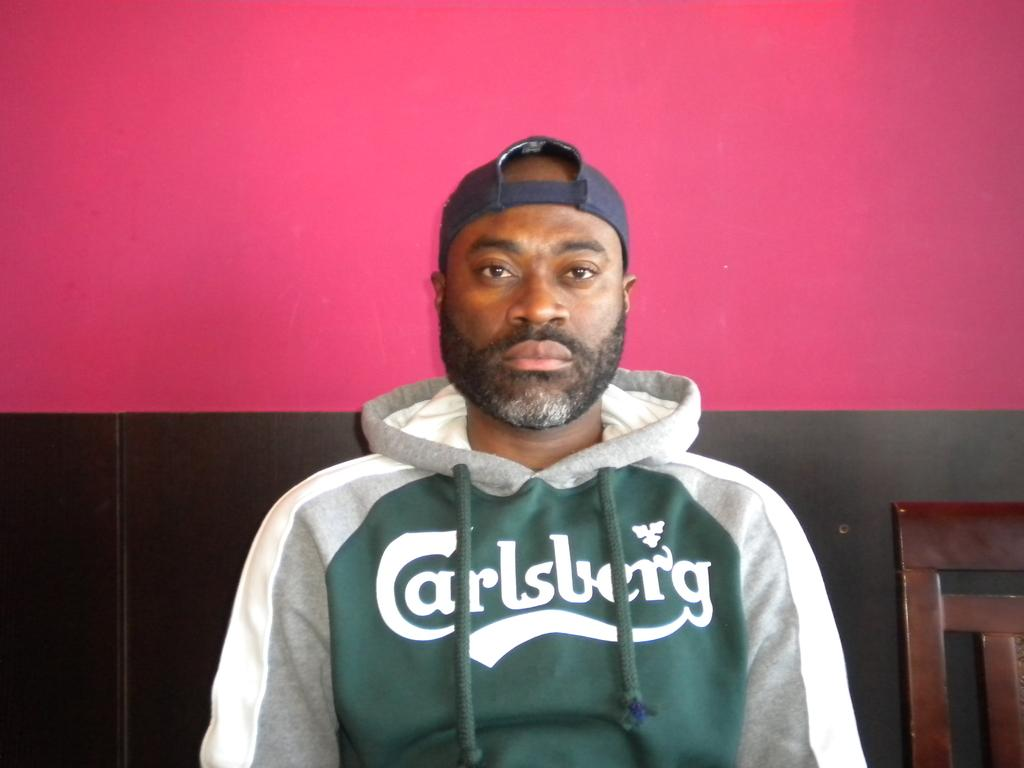<image>
Render a clear and concise summary of the photo. Green, gray, and white jacket with a Carlsberg logo wrote on front. 